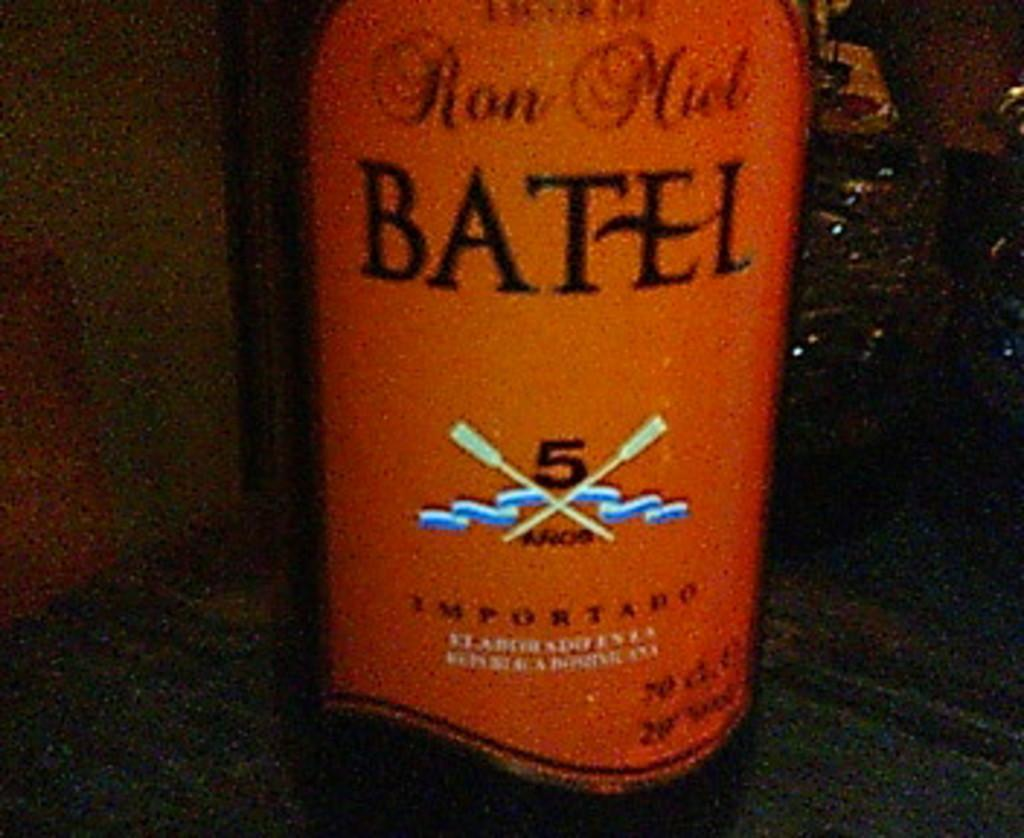<image>
Describe the image concisely. A bottle with a red label has the number five on it. 